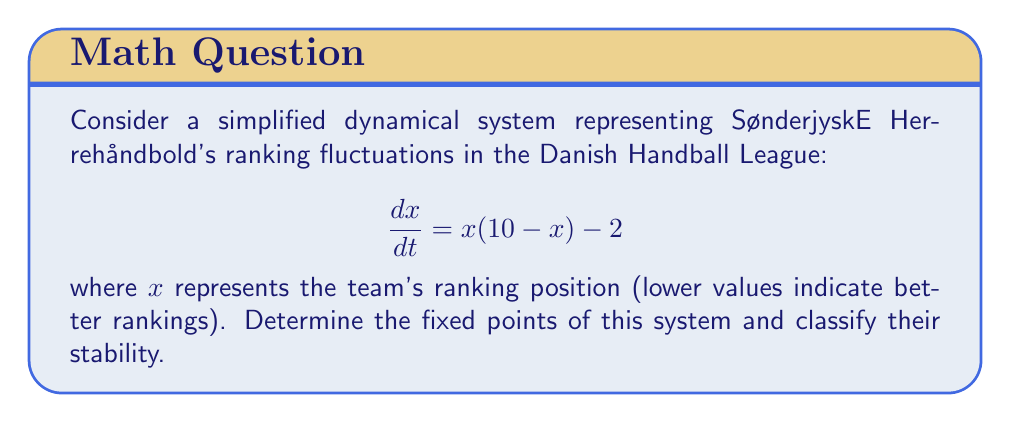Can you solve this math problem? 1. To find the fixed points, we set $\frac{dx}{dt} = 0$:

   $$x(10 - x) - 2 = 0$$

2. Expand the equation:

   $$10x - x^2 - 2 = 0$$

3. Rearrange to standard quadratic form:

   $$x^2 - 10x + 2 = 0$$

4. Solve using the quadratic formula: $x = \frac{-b \pm \sqrt{b^2 - 4ac}}{2a}$

   $$x = \frac{10 \pm \sqrt{100 - 8}}{2} = \frac{10 \pm \sqrt{92}}{2}$$

5. Simplify:

   $$x_1 = \frac{10 + \sqrt{92}}{2} \approx 9.79$$
   $$x_2 = \frac{10 - \sqrt{92}}{2} \approx 0.21$$

6. To classify stability, evaluate $\frac{d}{dx}(\frac{dx}{dt})$ at each fixed point:

   $$\frac{d}{dx}(\frac{dx}{dt}) = 10 - 2x$$

   At $x_1$: $10 - 2(9.79) = -9.58 < 0$ (stable)
   At $x_2$: $10 - 2(0.21) = 9.58 > 0$ (unstable)
Answer: Fixed points: $x_1 \approx 9.79$ (stable), $x_2 \approx 0.21$ (unstable) 